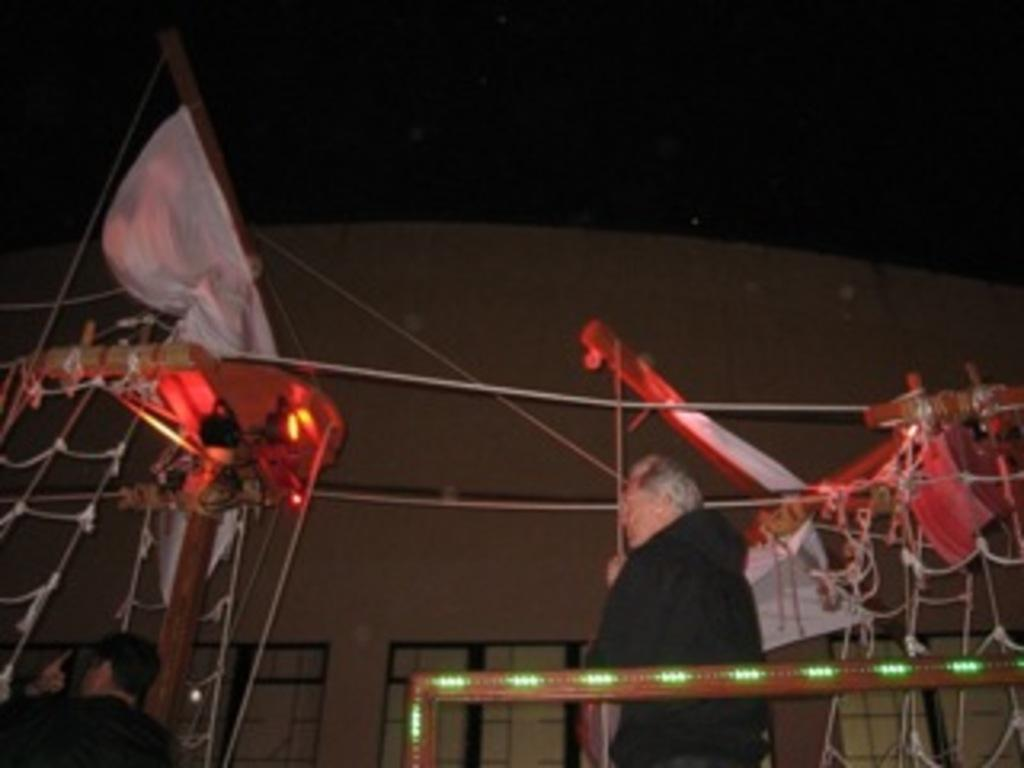How many people are in the image? There are two people in the image. What are the two people doing in the image? The two people are standing and looking somewhere. What can be observed about the background of the image? The background of the image is dark. What time does the hour hand point to in the image? There is no clock or hour hand present in the image. What type of rings can be seen on the fingers of the people in the image? There are no rings visible on the fingers of the people in the image. 